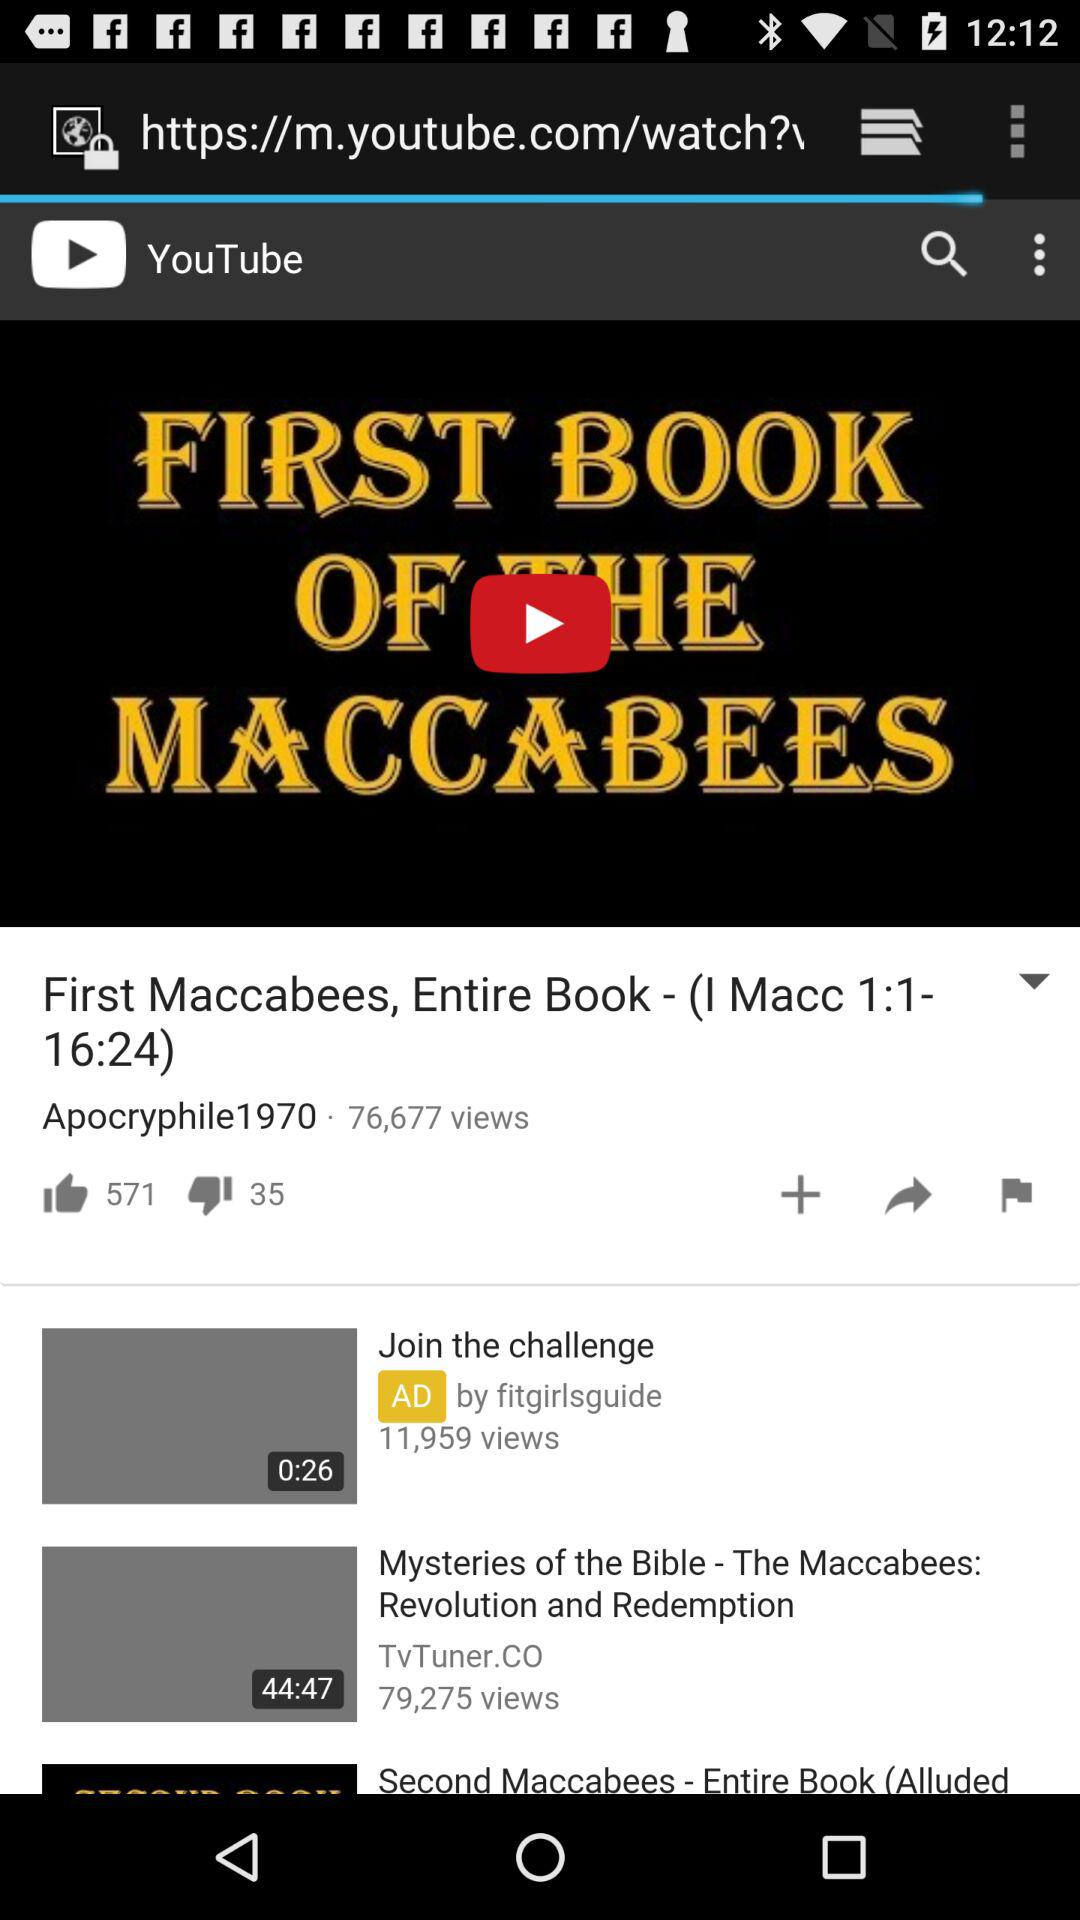How many views are there of "Mysteries of the Bible"? There are 79,275 views of "Mysteries of the Bible". 